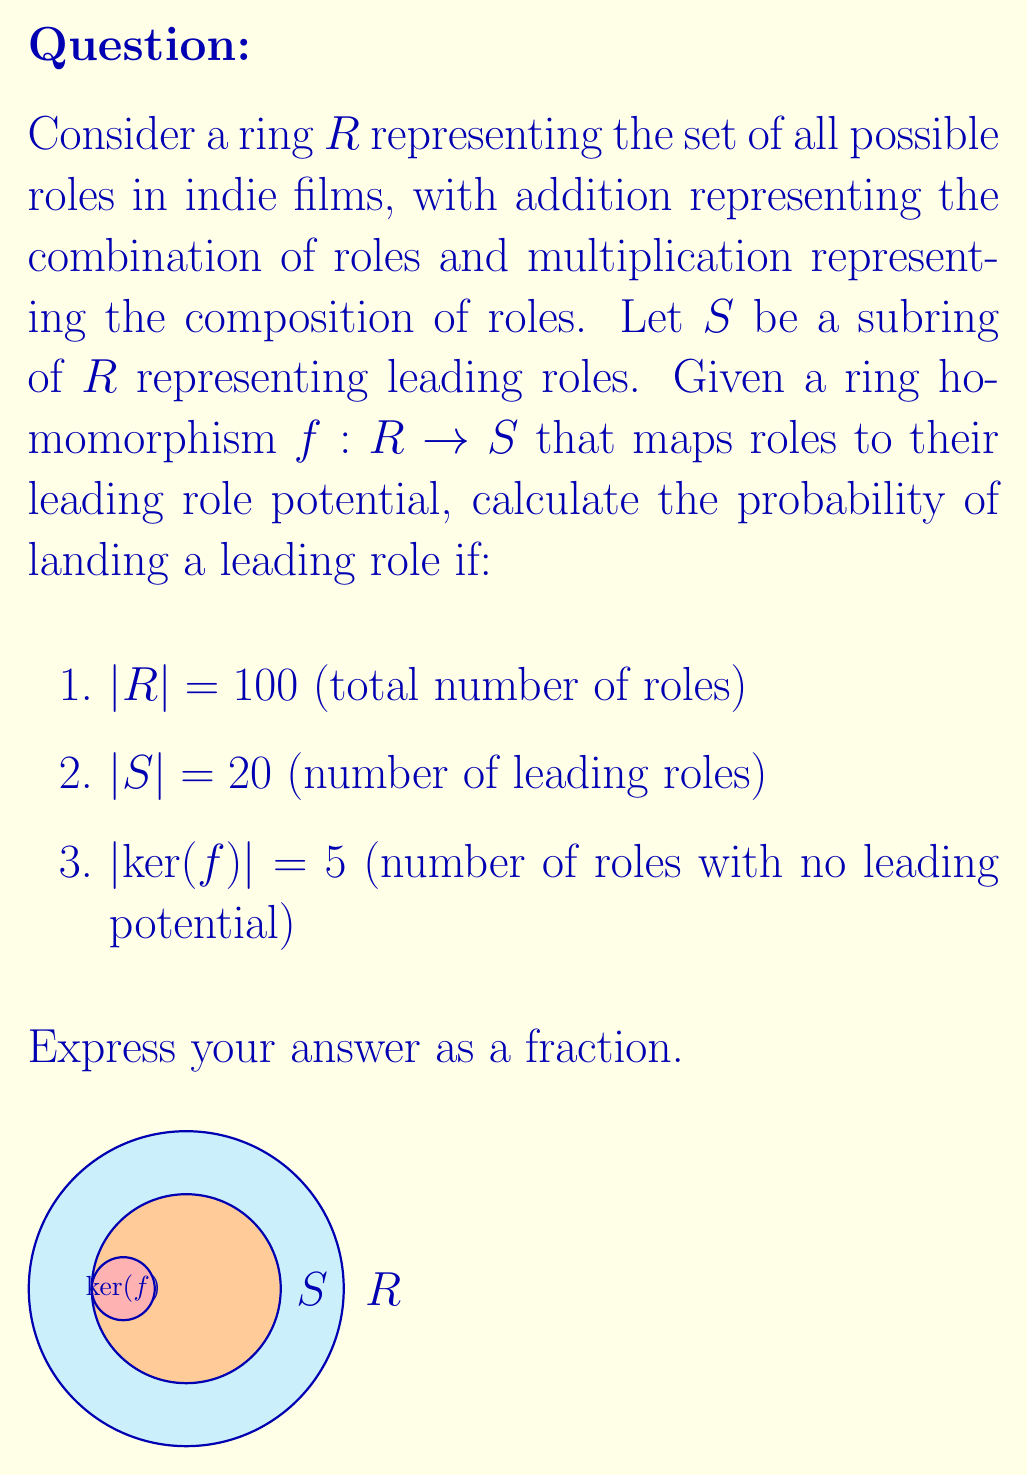Give your solution to this math problem. Let's approach this step-by-step using concepts from ring theory and probability:

1) First, recall the First Isomorphism Theorem for rings:
   $$R/\text{ker}(f) \cong \text{Im}(f)$$

2) This means that the size of the image of $f$ is:
   $$|\text{Im}(f)| = |R|/|\text{ker}(f)| = 100/5 = 20$$

3) Note that $|\text{Im}(f)| = |S|$, which confirms that $f$ is surjective onto $S$.

4) In probabilistic terms, each element in $R$ has an equal chance of being mapped to any element in $S$. This is because $f$ is a homomorphism and thus preserves the ring structure.

5) The probability of landing a leading role is equivalent to the probability of an element in $R$ being mapped to any element in $S$.

6) This probability is given by:
   $$P(\text{leading role}) = \frac{|S|}{|R|} = \frac{20}{100} = \frac{1}{5}$$

Therefore, the probability of landing a leading role is $\frac{1}{5}$ or $20\%$.
Answer: $\frac{1}{5}$ 